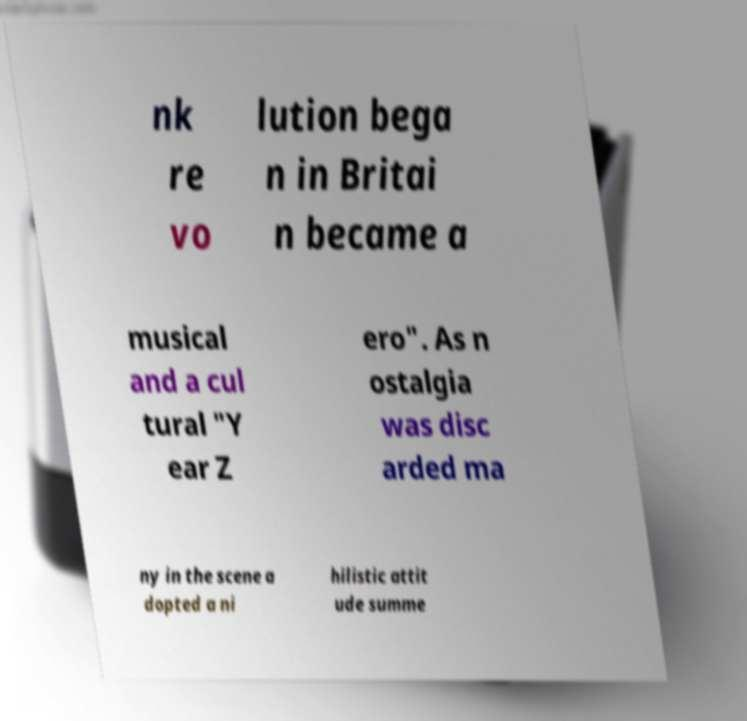Could you extract and type out the text from this image? nk re vo lution bega n in Britai n became a musical and a cul tural "Y ear Z ero". As n ostalgia was disc arded ma ny in the scene a dopted a ni hilistic attit ude summe 